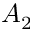Convert formula to latex. <formula><loc_0><loc_0><loc_500><loc_500>A _ { 2 }</formula> 